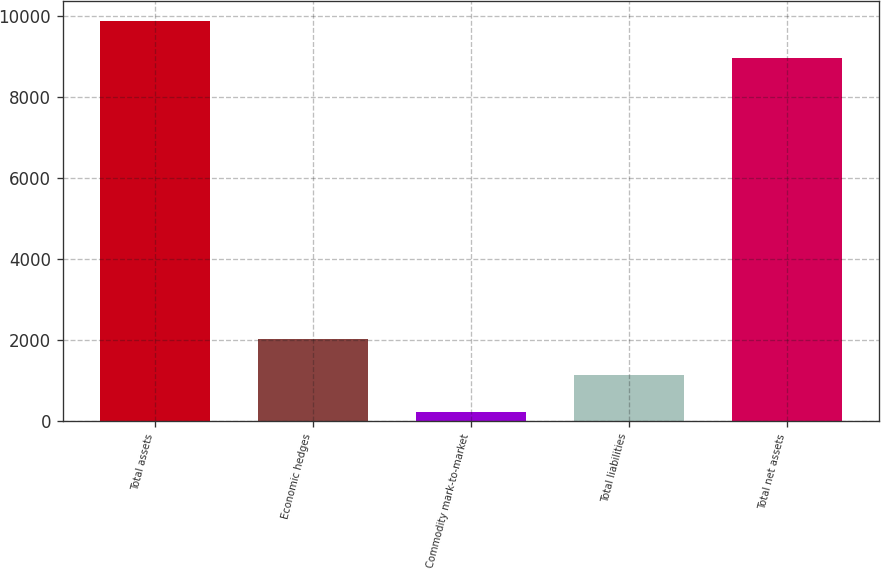<chart> <loc_0><loc_0><loc_500><loc_500><bar_chart><fcel>Total assets<fcel>Economic hedges<fcel>Commodity mark-to-market<fcel>Total liabilities<fcel>Total net assets<nl><fcel>9861.9<fcel>2028.8<fcel>219<fcel>1123.9<fcel>8957<nl></chart> 